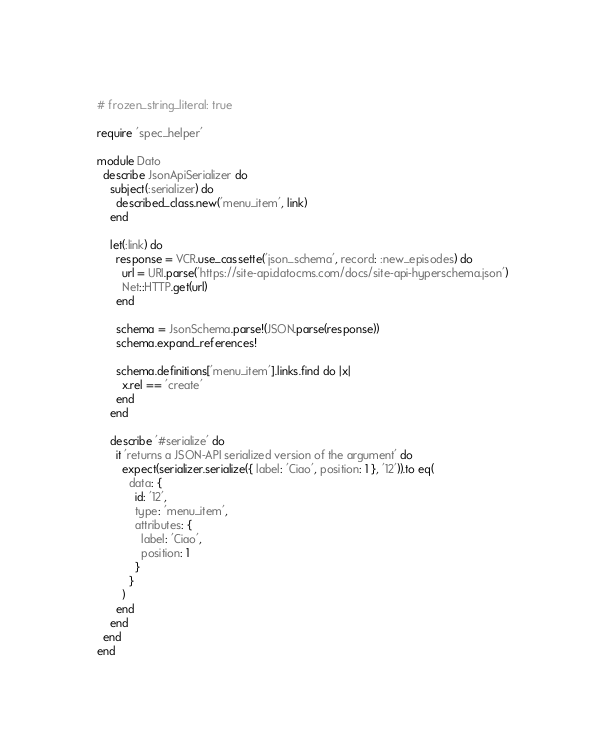<code> <loc_0><loc_0><loc_500><loc_500><_Ruby_># frozen_string_literal: true

require 'spec_helper'

module Dato
  describe JsonApiSerializer do
    subject(:serializer) do
      described_class.new('menu_item', link)
    end

    let(:link) do
      response = VCR.use_cassette('json_schema', record: :new_episodes) do
        url = URI.parse('https://site-api.datocms.com/docs/site-api-hyperschema.json')
        Net::HTTP.get(url)
      end

      schema = JsonSchema.parse!(JSON.parse(response))
      schema.expand_references!

      schema.definitions['menu_item'].links.find do |x|
        x.rel == 'create'
      end
    end

    describe '#serialize' do
      it 'returns a JSON-API serialized version of the argument' do
        expect(serializer.serialize({ label: 'Ciao', position: 1 }, '12')).to eq(
          data: {
            id: '12',
            type: 'menu_item',
            attributes: {
              label: 'Ciao',
              position: 1
            }
          }
        )
      end
    end
  end
end
</code> 